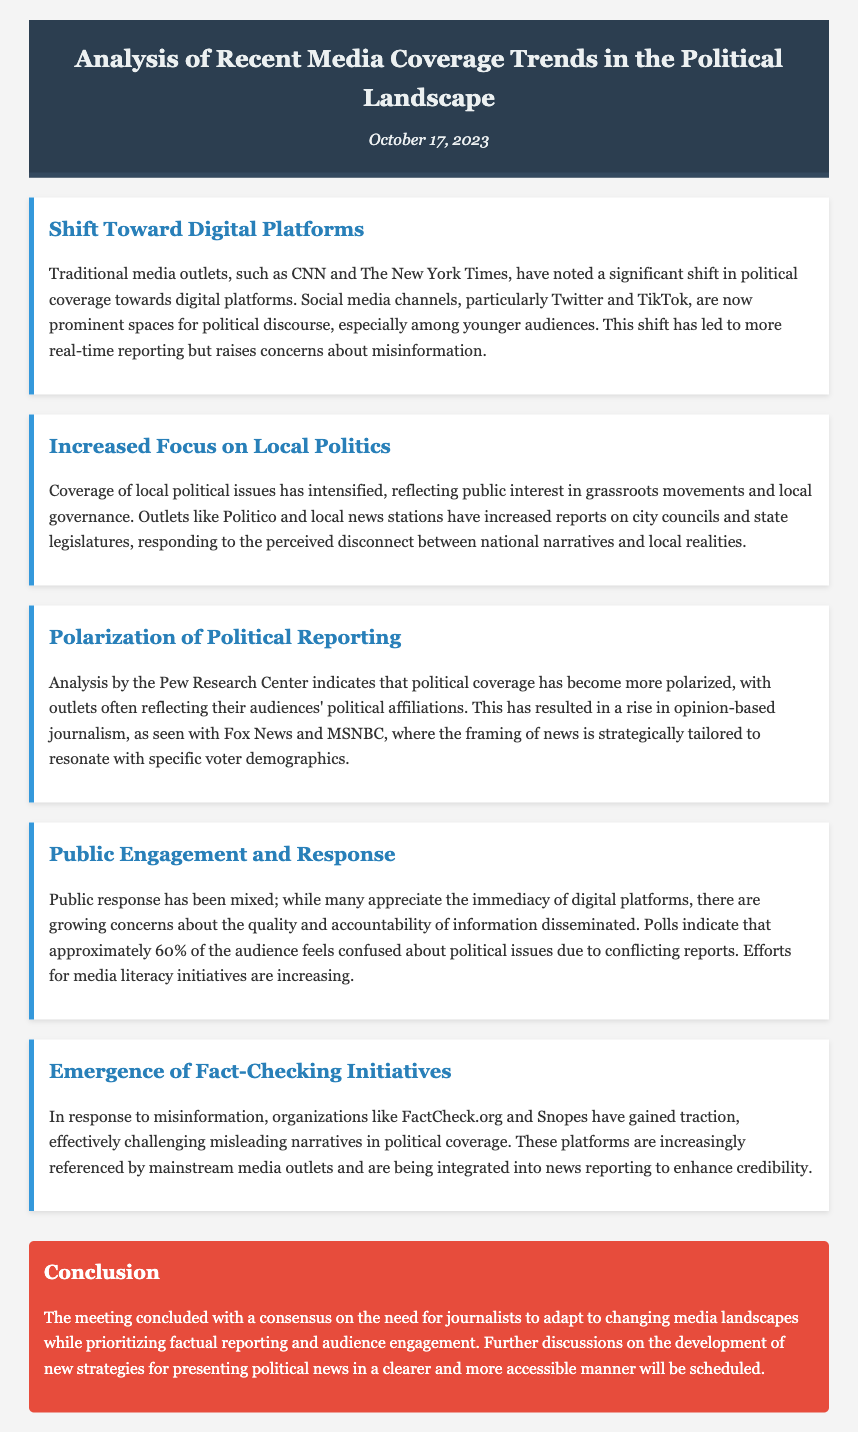What is the date of the meeting? The date of the meeting is mentioned in the header of the document.
Answer: October 17, 2023 Which platforms are noted for a significant shift in political coverage? The document highlights the shift towards digital platforms, specifically mentioning social media channels.
Answer: Digital platforms What percentage of the audience feels confused about political issues? The document states that approximately 60% of the audience expresses confusion about political issues.
Answer: 60% What trend is indicated by the Pew Research Center analysis? The analysis noted in the document points to the polarization of political reporting among media outlets.
Answer: Polarization Which organizations are mentioned as fact-checking initiatives? The meeting minutes identify FactCheck.org and Snopes as examples of fact-checking organizations.
Answer: FactCheck.org and Snopes What type of journalism has increased according to the document? The document discusses the rise of opinion-based journalism in political coverage.
Answer: Opinion-based journalism What conclusion was reached during the meeting? The document notes a consensus on the necessity for journalists to adapt and prioritize factual reporting.
Answer: Adapt to changing media landscapes Which local news outlets are mentioned in relation to increased reporting? The document cites Politico and local news stations regarding their focus on local political issues.
Answer: Politico and local news stations 